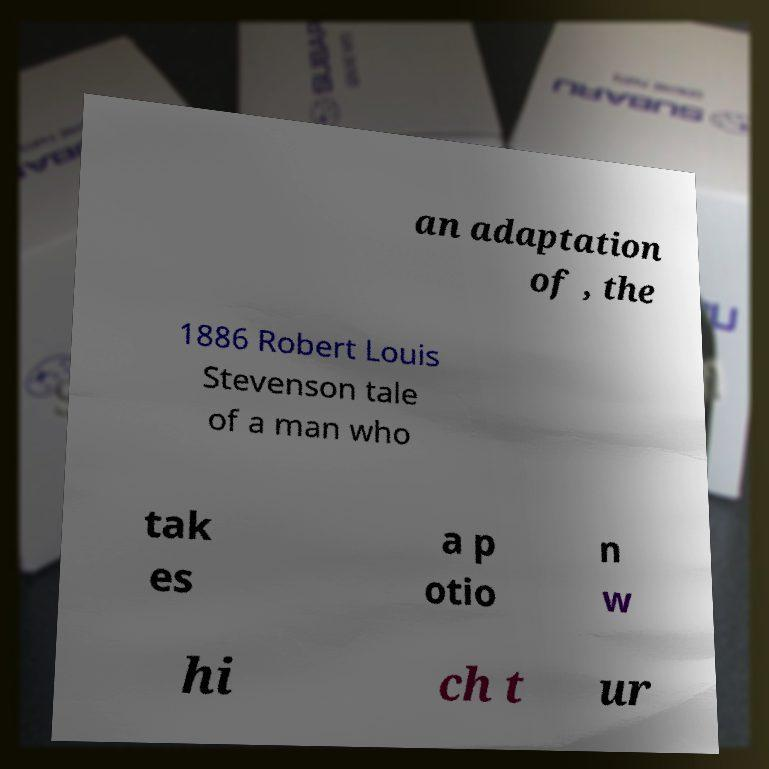Can you read and provide the text displayed in the image?This photo seems to have some interesting text. Can you extract and type it out for me? an adaptation of , the 1886 Robert Louis Stevenson tale of a man who tak es a p otio n w hi ch t ur 